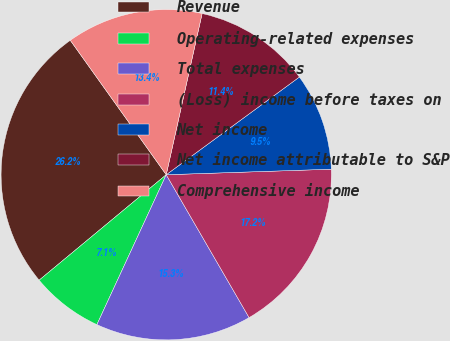Convert chart to OTSL. <chart><loc_0><loc_0><loc_500><loc_500><pie_chart><fcel>Revenue<fcel>Operating-related expenses<fcel>Total expenses<fcel>(Loss) income before taxes on<fcel>Net income<fcel>Net income attributable to S&P<fcel>Comprehensive income<nl><fcel>26.16%<fcel>7.08%<fcel>15.26%<fcel>17.17%<fcel>9.54%<fcel>11.44%<fcel>13.35%<nl></chart> 